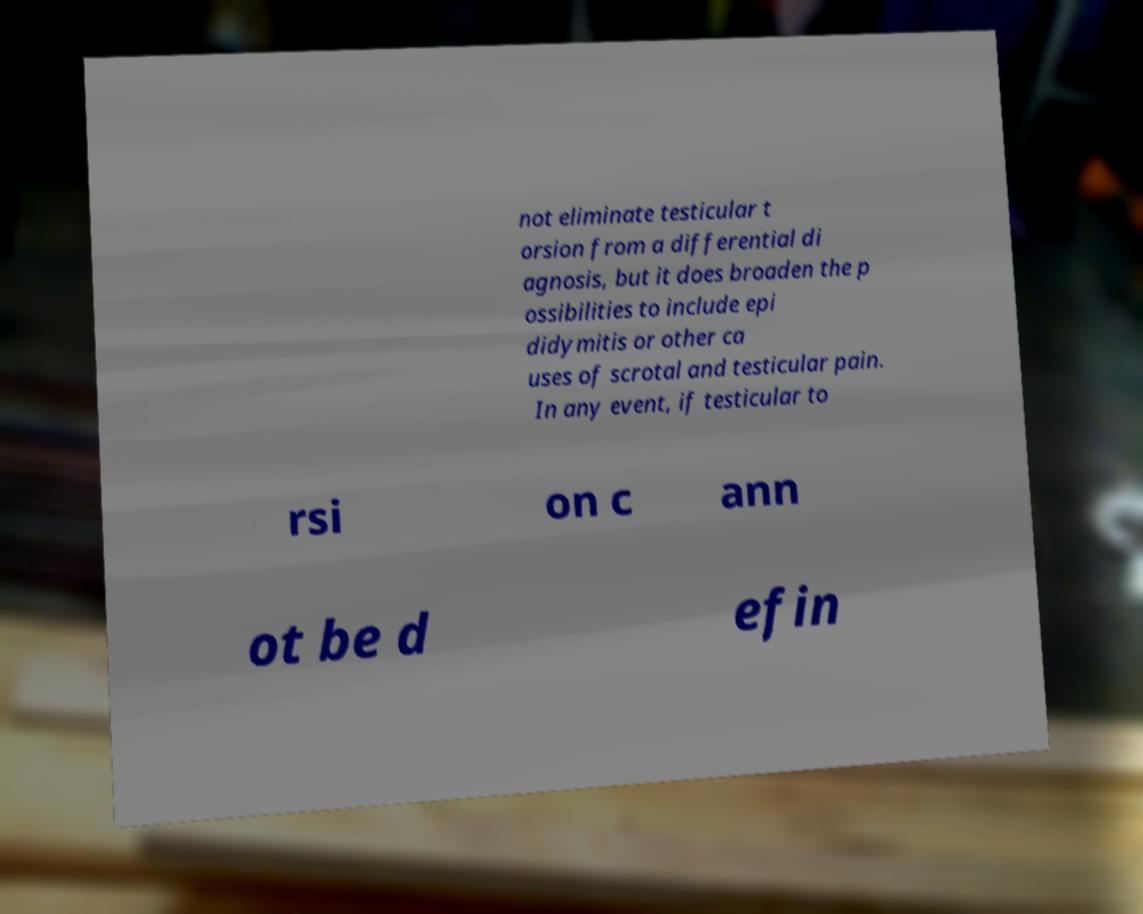What messages or text are displayed in this image? I need them in a readable, typed format. not eliminate testicular t orsion from a differential di agnosis, but it does broaden the p ossibilities to include epi didymitis or other ca uses of scrotal and testicular pain. In any event, if testicular to rsi on c ann ot be d efin 